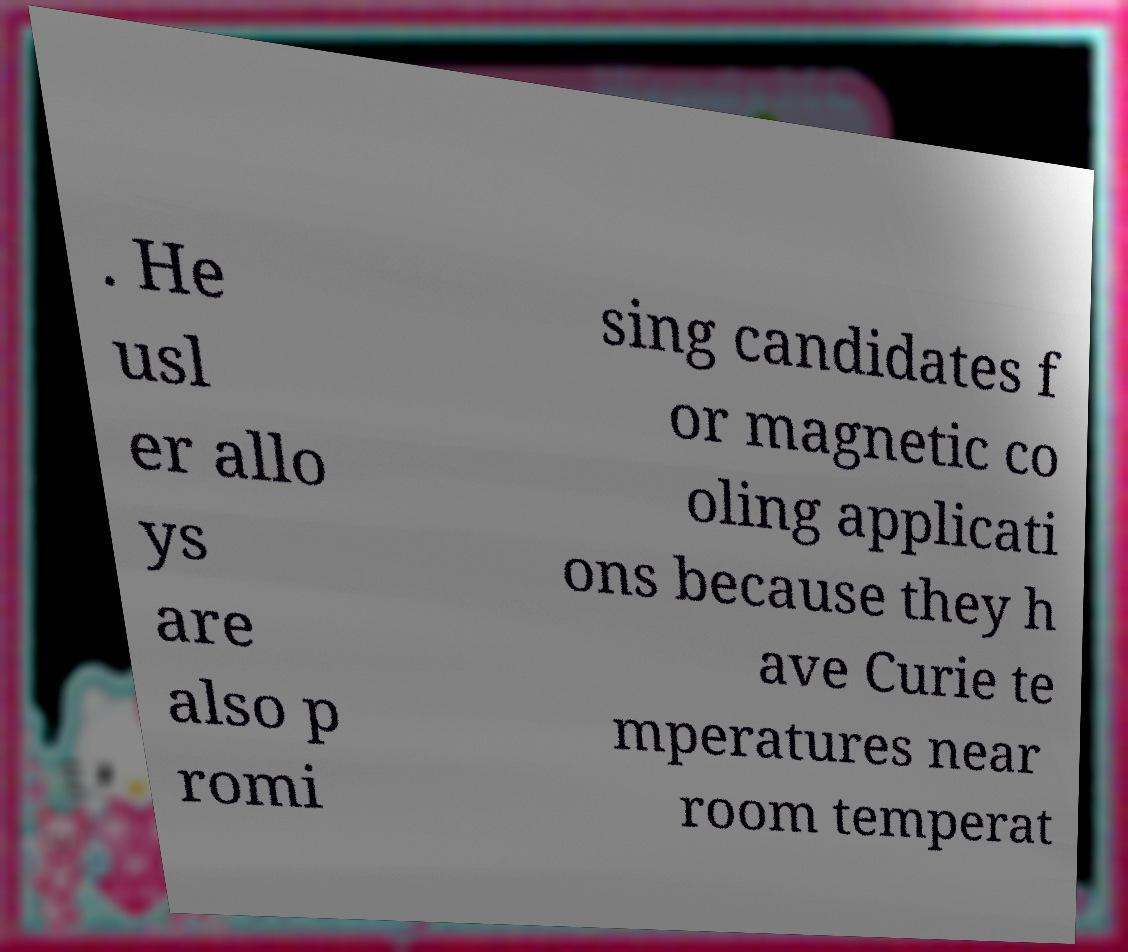Could you assist in decoding the text presented in this image and type it out clearly? . He usl er allo ys are also p romi sing candidates f or magnetic co oling applicati ons because they h ave Curie te mperatures near room temperat 